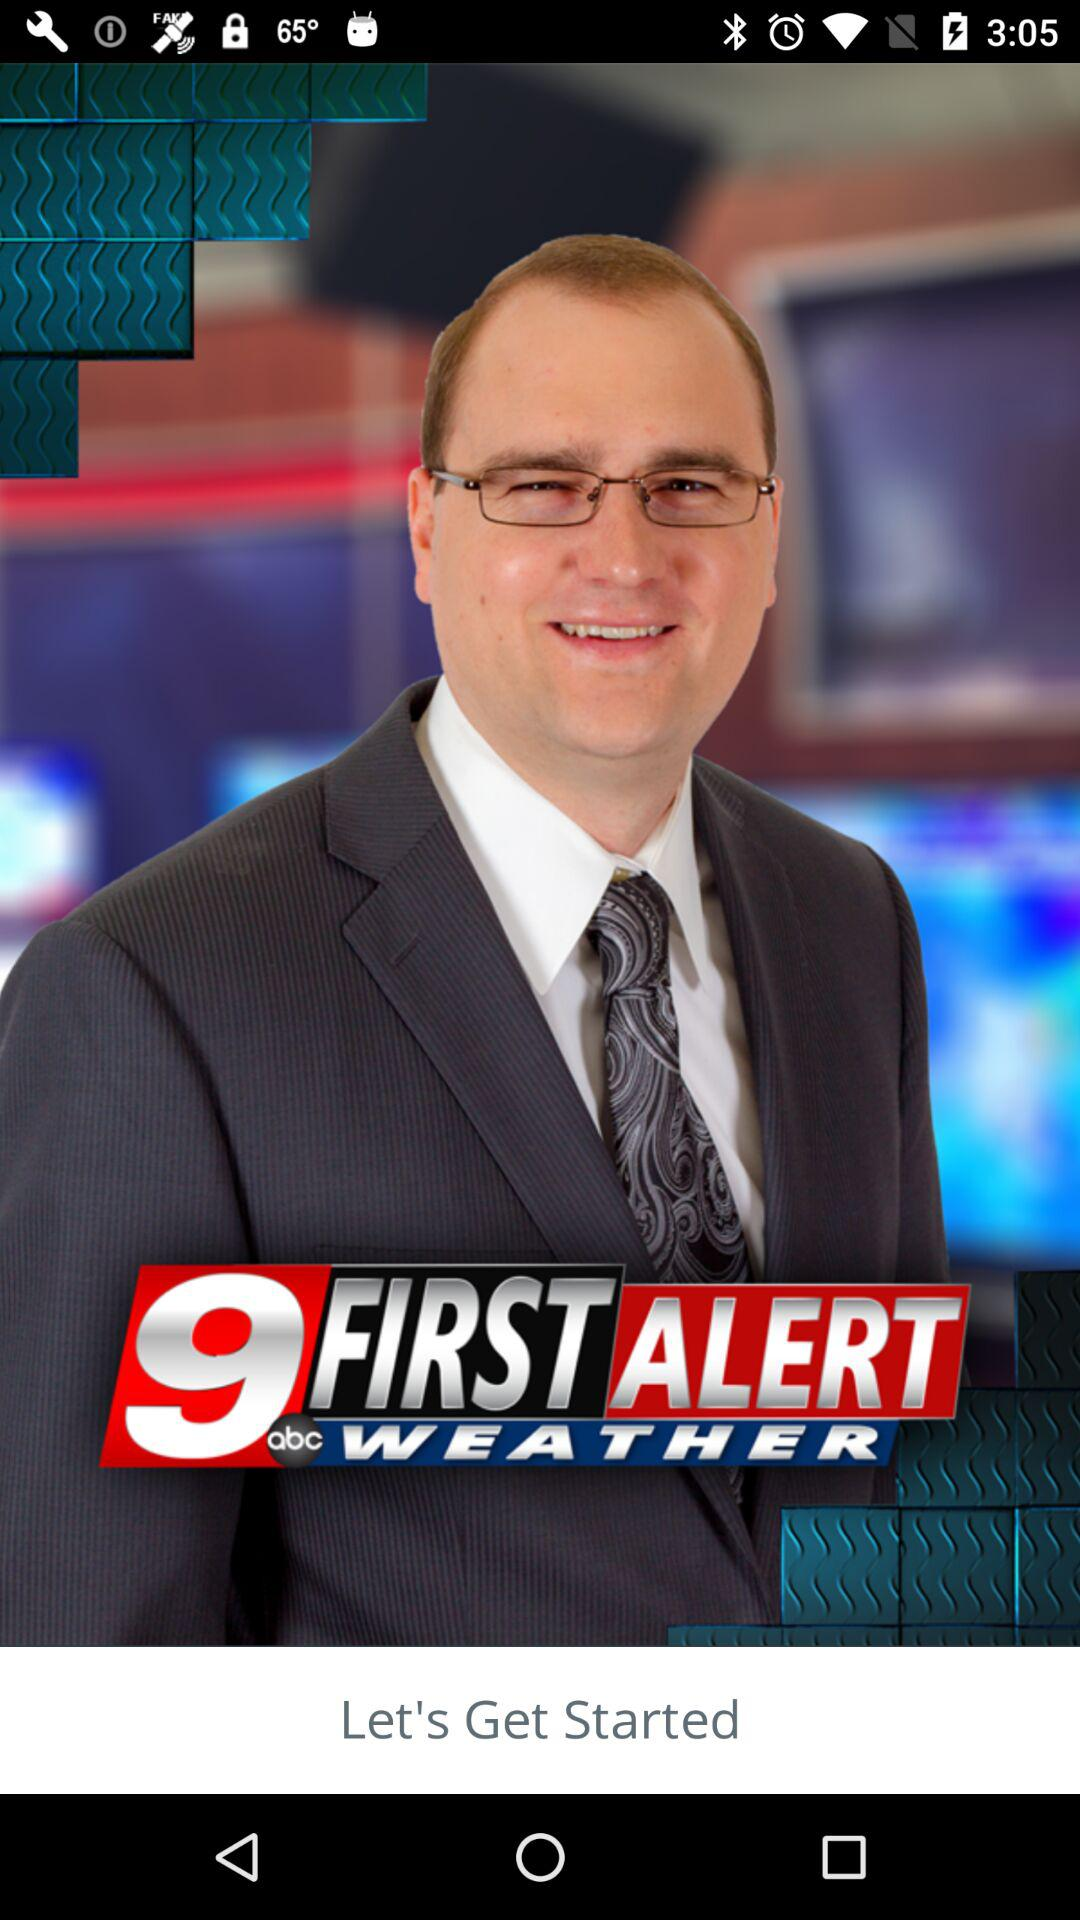What is the name of the application? The name of the application is "KTRE 9 First Alert Weather". 